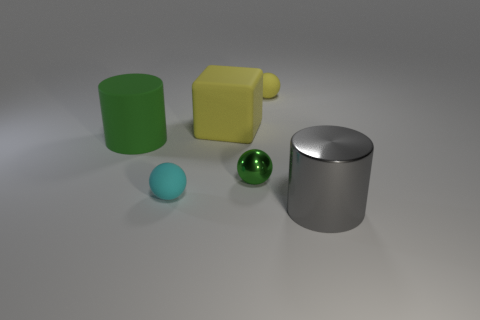Add 1 tiny yellow rubber balls. How many objects exist? 7 Subtract all blocks. How many objects are left? 5 Add 2 yellow objects. How many yellow objects are left? 4 Add 3 large yellow cubes. How many large yellow cubes exist? 4 Subtract 0 purple balls. How many objects are left? 6 Subtract all large yellow objects. Subtract all large yellow things. How many objects are left? 4 